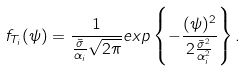Convert formula to latex. <formula><loc_0><loc_0><loc_500><loc_500>f _ { T _ { i } } ( \psi ) = \frac { 1 } { \frac { \bar { \sigma } } { \alpha _ { i } } \sqrt { 2 \pi } } e x p \left \{ - \frac { ( \psi ) ^ { 2 } } { 2 \frac { \bar { \sigma } ^ { 2 } } { \alpha _ { i } ^ { 2 } } } \right \} .</formula> 